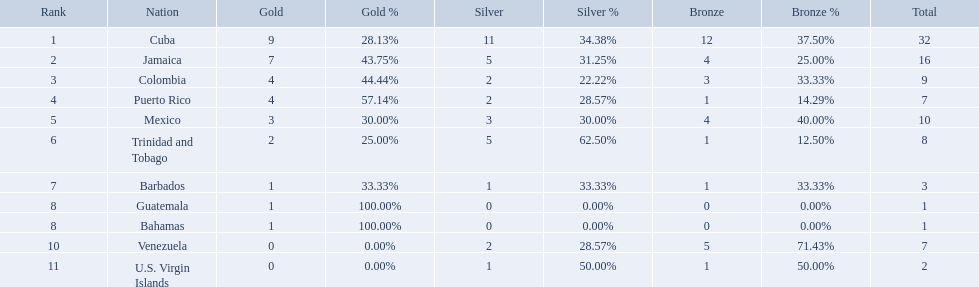What teams had four gold medals? Colombia, Puerto Rico. Of these two, which team only had one bronze medal? Puerto Rico. What nation has won at least 4 gold medals? Cuba, Jamaica, Colombia, Puerto Rico. Of these countries who has won the least amount of bronze medals? Puerto Rico. Which nations played in the games? Cuba, Jamaica, Colombia, Puerto Rico, Mexico, Trinidad and Tobago, Barbados, Guatemala, Bahamas, Venezuela, U.S. Virgin Islands. How many silver medals did they win? 11, 5, 2, 2, 3, 5, 1, 0, 0, 2, 1. Which team won the most silver? Cuba. Which countries competed in the 1966 central american and caribbean games? Cuba, Jamaica, Colombia, Puerto Rico, Mexico, Trinidad and Tobago, Barbados, Guatemala, Bahamas, Venezuela, U.S. Virgin Islands. Which countries won at least six silver medals at these games? Cuba. 